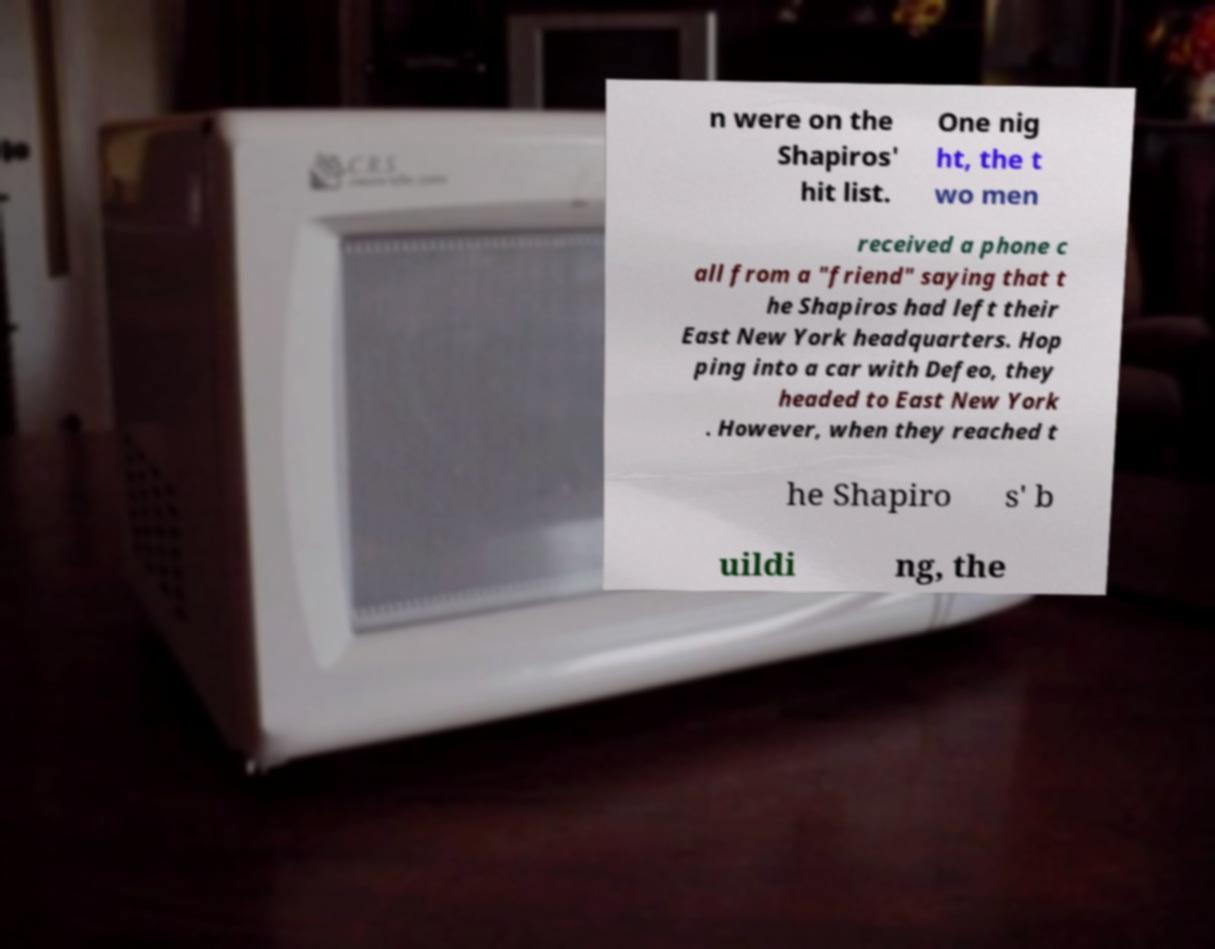For documentation purposes, I need the text within this image transcribed. Could you provide that? n were on the Shapiros' hit list. One nig ht, the t wo men received a phone c all from a "friend" saying that t he Shapiros had left their East New York headquarters. Hop ping into a car with Defeo, they headed to East New York . However, when they reached t he Shapiro s' b uildi ng, the 